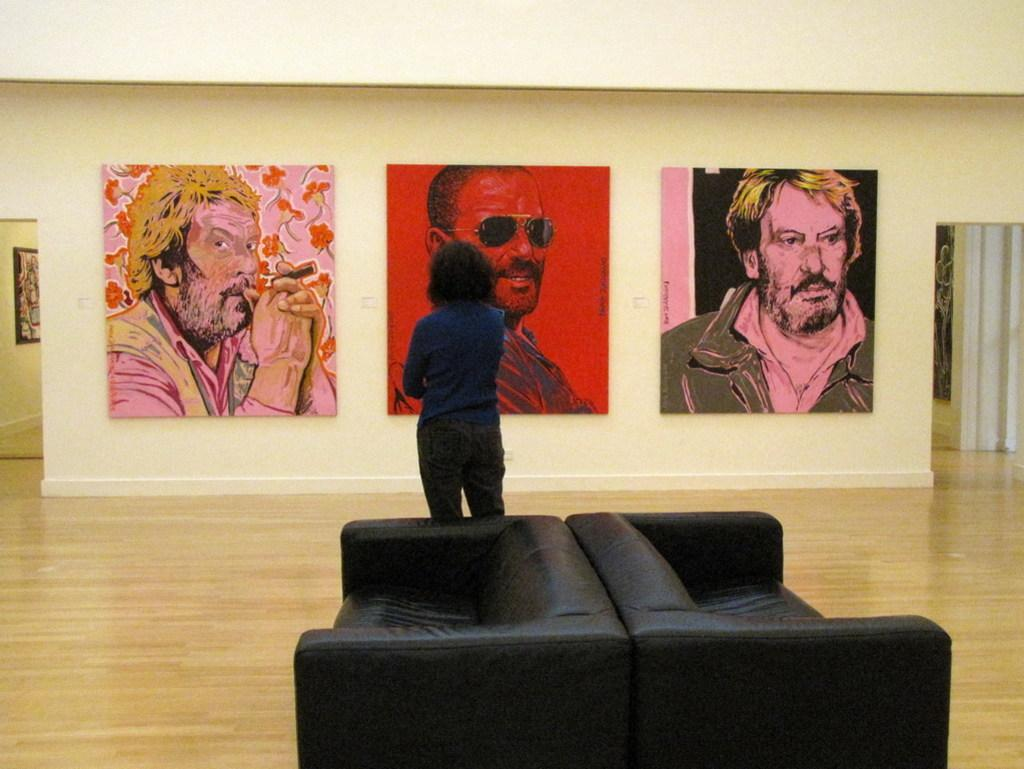What is the person in the image doing? The person is standing on the floor and looking at posters. What are the posters depicting? The posters are of another person. What furniture is present in the image? There are two sofas beside the person. What can be seen on the wall in the background of the image? There is a frame on the wall. What type of grain is being harvested in the image? There is no grain or harvesting activity present in the image. 